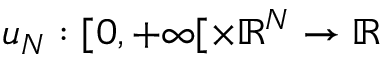<formula> <loc_0><loc_0><loc_500><loc_500>u _ { N } \colon [ 0 , + \infty [ \times \mathbb { R } ^ { N } \to \mathbb { R }</formula> 